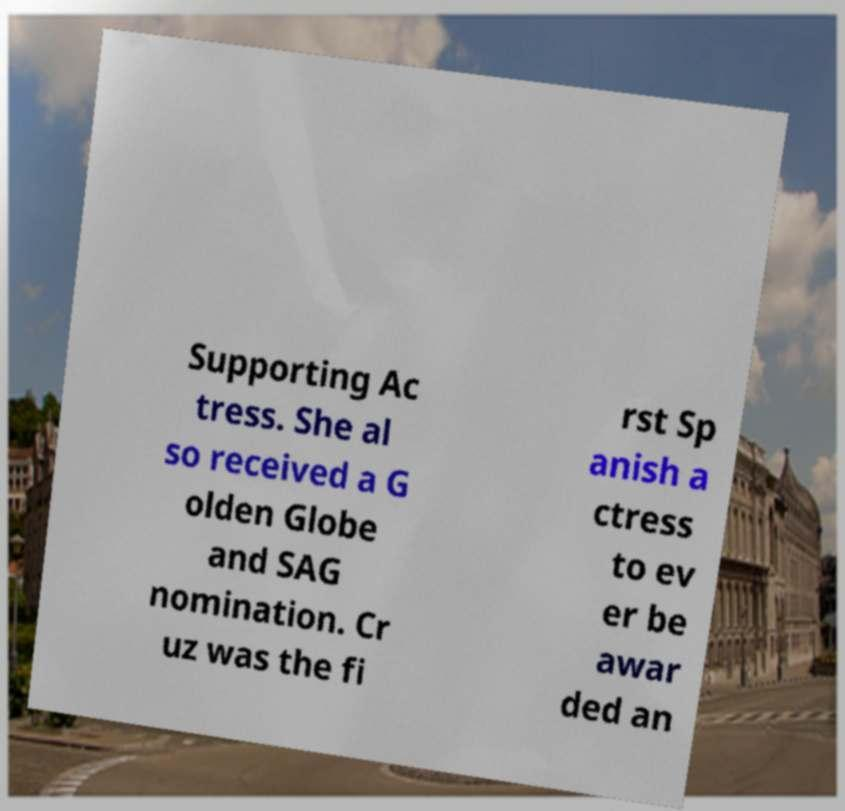Could you assist in decoding the text presented in this image and type it out clearly? Supporting Ac tress. She al so received a G olden Globe and SAG nomination. Cr uz was the fi rst Sp anish a ctress to ev er be awar ded an 